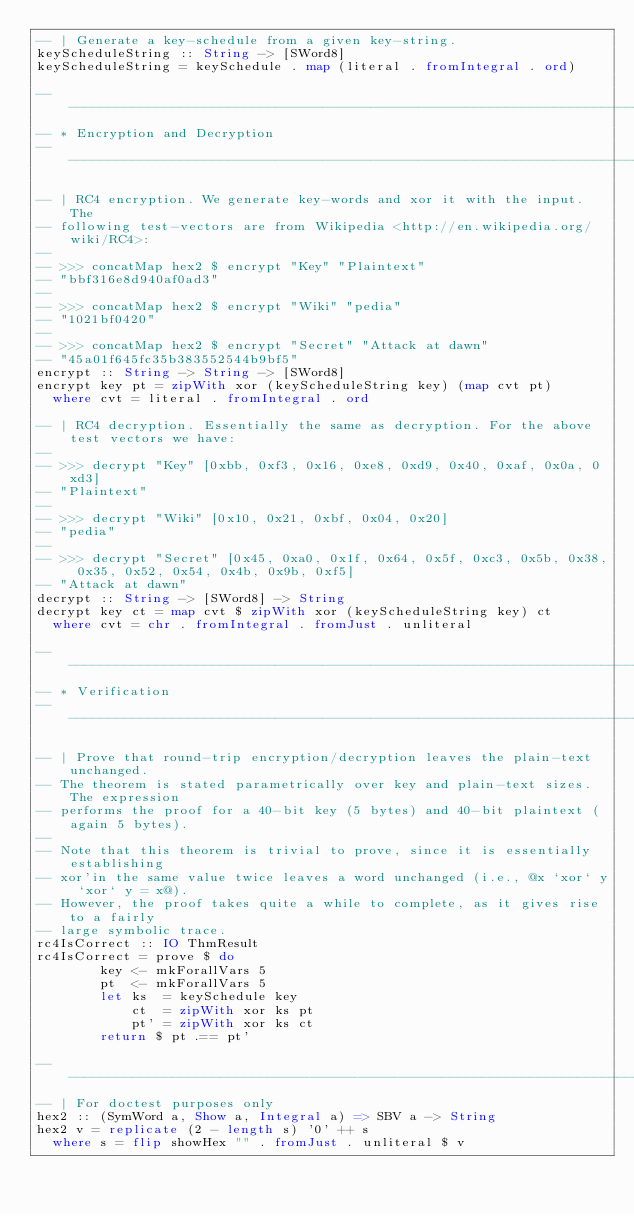Convert code to text. <code><loc_0><loc_0><loc_500><loc_500><_Haskell_>-- | Generate a key-schedule from a given key-string.
keyScheduleString :: String -> [SWord8]
keyScheduleString = keySchedule . map (literal . fromIntegral . ord)

-----------------------------------------------------------------------------
-- * Encryption and Decryption
-----------------------------------------------------------------------------

-- | RC4 encryption. We generate key-words and xor it with the input. The
-- following test-vectors are from Wikipedia <http://en.wikipedia.org/wiki/RC4>:
--
-- >>> concatMap hex2 $ encrypt "Key" "Plaintext"
-- "bbf316e8d940af0ad3"
--
-- >>> concatMap hex2 $ encrypt "Wiki" "pedia"
-- "1021bf0420"
--
-- >>> concatMap hex2 $ encrypt "Secret" "Attack at dawn"
-- "45a01f645fc35b383552544b9bf5"
encrypt :: String -> String -> [SWord8]
encrypt key pt = zipWith xor (keyScheduleString key) (map cvt pt)
  where cvt = literal . fromIntegral . ord

-- | RC4 decryption. Essentially the same as decryption. For the above test vectors we have:
--
-- >>> decrypt "Key" [0xbb, 0xf3, 0x16, 0xe8, 0xd9, 0x40, 0xaf, 0x0a, 0xd3]
-- "Plaintext"
--
-- >>> decrypt "Wiki" [0x10, 0x21, 0xbf, 0x04, 0x20]
-- "pedia"
--
-- >>> decrypt "Secret" [0x45, 0xa0, 0x1f, 0x64, 0x5f, 0xc3, 0x5b, 0x38, 0x35, 0x52, 0x54, 0x4b, 0x9b, 0xf5]
-- "Attack at dawn"
decrypt :: String -> [SWord8] -> String
decrypt key ct = map cvt $ zipWith xor (keyScheduleString key) ct
  where cvt = chr . fromIntegral . fromJust . unliteral

-----------------------------------------------------------------------------
-- * Verification
-----------------------------------------------------------------------------

-- | Prove that round-trip encryption/decryption leaves the plain-text unchanged.
-- The theorem is stated parametrically over key and plain-text sizes. The expression
-- performs the proof for a 40-bit key (5 bytes) and 40-bit plaintext (again 5 bytes).
--
-- Note that this theorem is trivial to prove, since it is essentially establishing
-- xor'in the same value twice leaves a word unchanged (i.e., @x `xor` y `xor` y = x@).
-- However, the proof takes quite a while to complete, as it gives rise to a fairly
-- large symbolic trace.
rc4IsCorrect :: IO ThmResult
rc4IsCorrect = prove $ do
        key <- mkForallVars 5
        pt  <- mkForallVars 5
        let ks  = keySchedule key
            ct  = zipWith xor ks pt
            pt' = zipWith xor ks ct
        return $ pt .== pt'

--------------------------------------------------------------------------------------------
-- | For doctest purposes only
hex2 :: (SymWord a, Show a, Integral a) => SBV a -> String
hex2 v = replicate (2 - length s) '0' ++ s
  where s = flip showHex "" . fromJust . unliteral $ v
</code> 